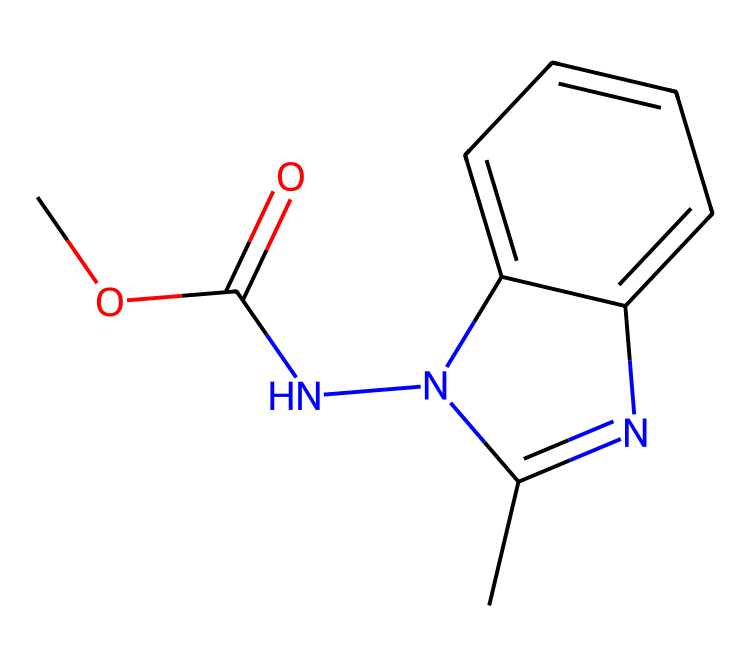What is the molecular formula of carbendazim? To find the molecular formula, count the number of carbon (C), hydrogen (H), nitrogen (N), and oxygen (O) atoms in the structure. The molecule contains 9 carbon atoms, 9 hydrogen atoms, 4 nitrogen atoms, and 1 oxygen atom, leading to the formula C9H9N4O.
Answer: C9H9N4O How many nitrogen atoms are present in the structure? By inspecting the SMILES representation, we see that nitrogen (N) appears multiple times. Specifically, there are four nitrogen atoms in the entire structure.
Answer: 4 What functional group is present in carbendazim? The presence of the carbonyl group (C=O) and the oxygen connected by a single bond to a carbon (O-C) indicates that there is an ester functional group in the structure.
Answer: ester What is the significance of the central carbon atom in the structure? The central carbon atom is part of the carbonyl functional group, which is crucial for the bioactivity of fungicides. This carbonyl contributes to the molecule's reactivity and ability to interact with fungal cell components.
Answer: bioactivity Which atoms are part of the heterocyclic ring in carbendazim? The heterocyclic ring consists of nitrogen and carbon atoms that form a closed ring. By examining the SMILES, the two nitrogen atoms and the multiple carbon atoms make up this ring structure.
Answer: nitrogen and carbon What type of compound is carbendazim classified as? Carbendazim is primarily classified as a benzimidazole fungicide based on its structural features and its primary use as a fungicide in agriculture and textiles.
Answer: benzimidazole 